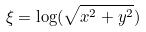<formula> <loc_0><loc_0><loc_500><loc_500>\xi = \log ( \sqrt { x ^ { 2 } + y ^ { 2 } } )</formula> 